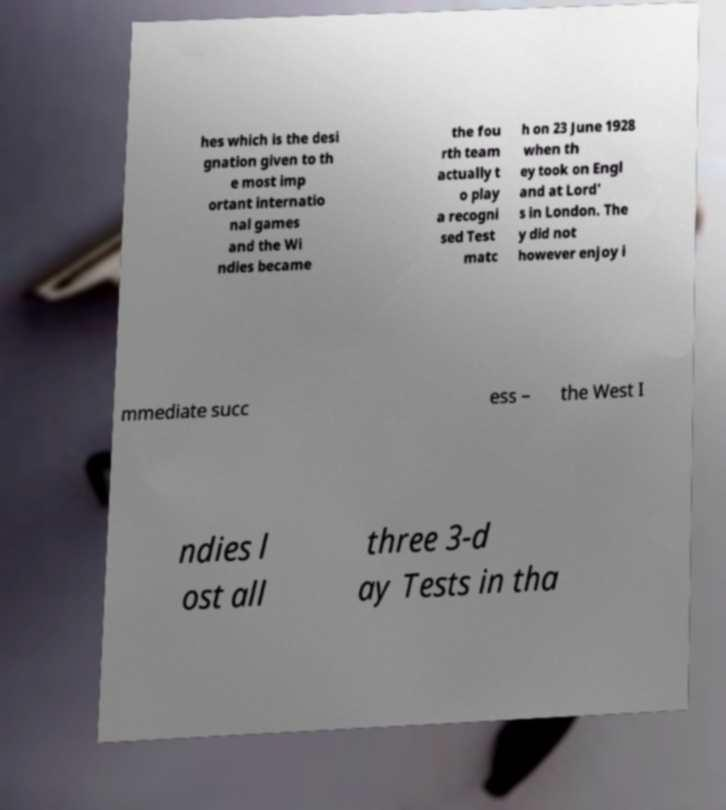Can you accurately transcribe the text from the provided image for me? hes which is the desi gnation given to th e most imp ortant internatio nal games and the Wi ndies became the fou rth team actually t o play a recogni sed Test matc h on 23 June 1928 when th ey took on Engl and at Lord' s in London. The y did not however enjoy i mmediate succ ess – the West I ndies l ost all three 3-d ay Tests in tha 